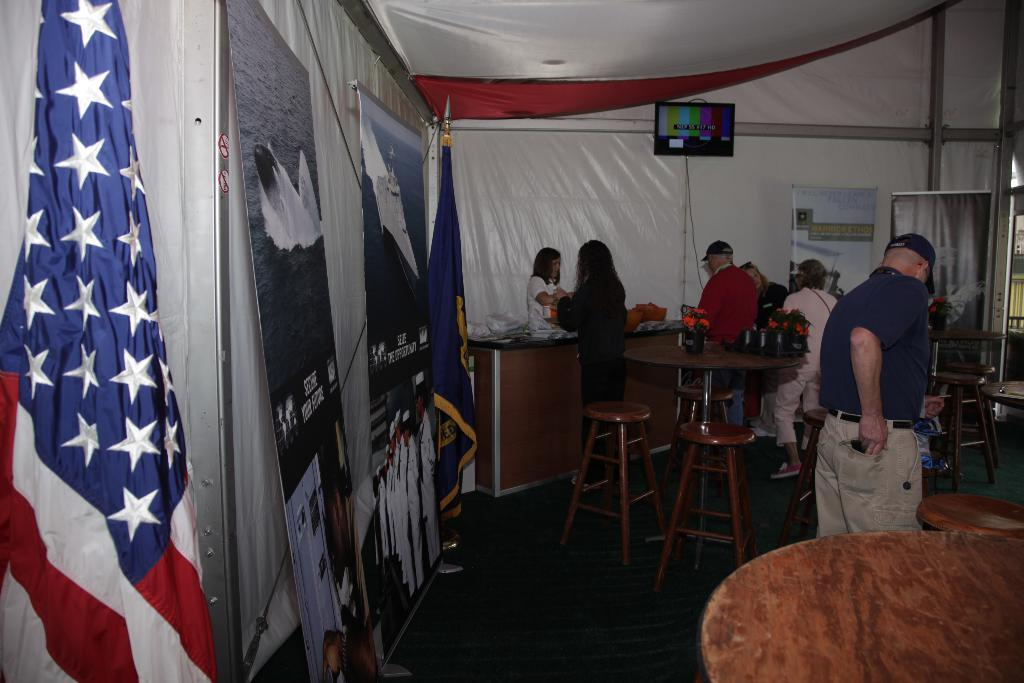What can be seen in the image involving people? There are people standing in the image. What type of furniture is present in the image? There are stools and tables in the image. What is located in the background of the image? There is a television in the background of the image. What decorative elements are present in the image? There are flags in the image. What type of cactus is present in the image? There is no cactus present in the image. 